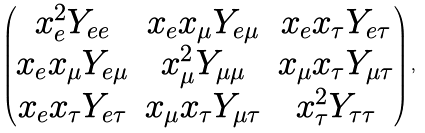<formula> <loc_0><loc_0><loc_500><loc_500>\begin{pmatrix} x _ { e } ^ { 2 } Y _ { e e } & x _ { e } x _ { \mu } Y _ { e \mu } & x _ { e } x _ { \tau } Y _ { e \tau } \\ x _ { e } x _ { \mu } Y _ { e \mu } & x _ { \mu } ^ { 2 } Y _ { \mu \mu } & x _ { \mu } x _ { \tau } Y _ { \mu \tau } \\ x _ { e } x _ { \tau } Y _ { e \tau } & x _ { \mu } x _ { \tau } Y _ { \mu \tau } & x _ { \tau } ^ { 2 } Y _ { \tau \tau } \end{pmatrix} ,</formula> 